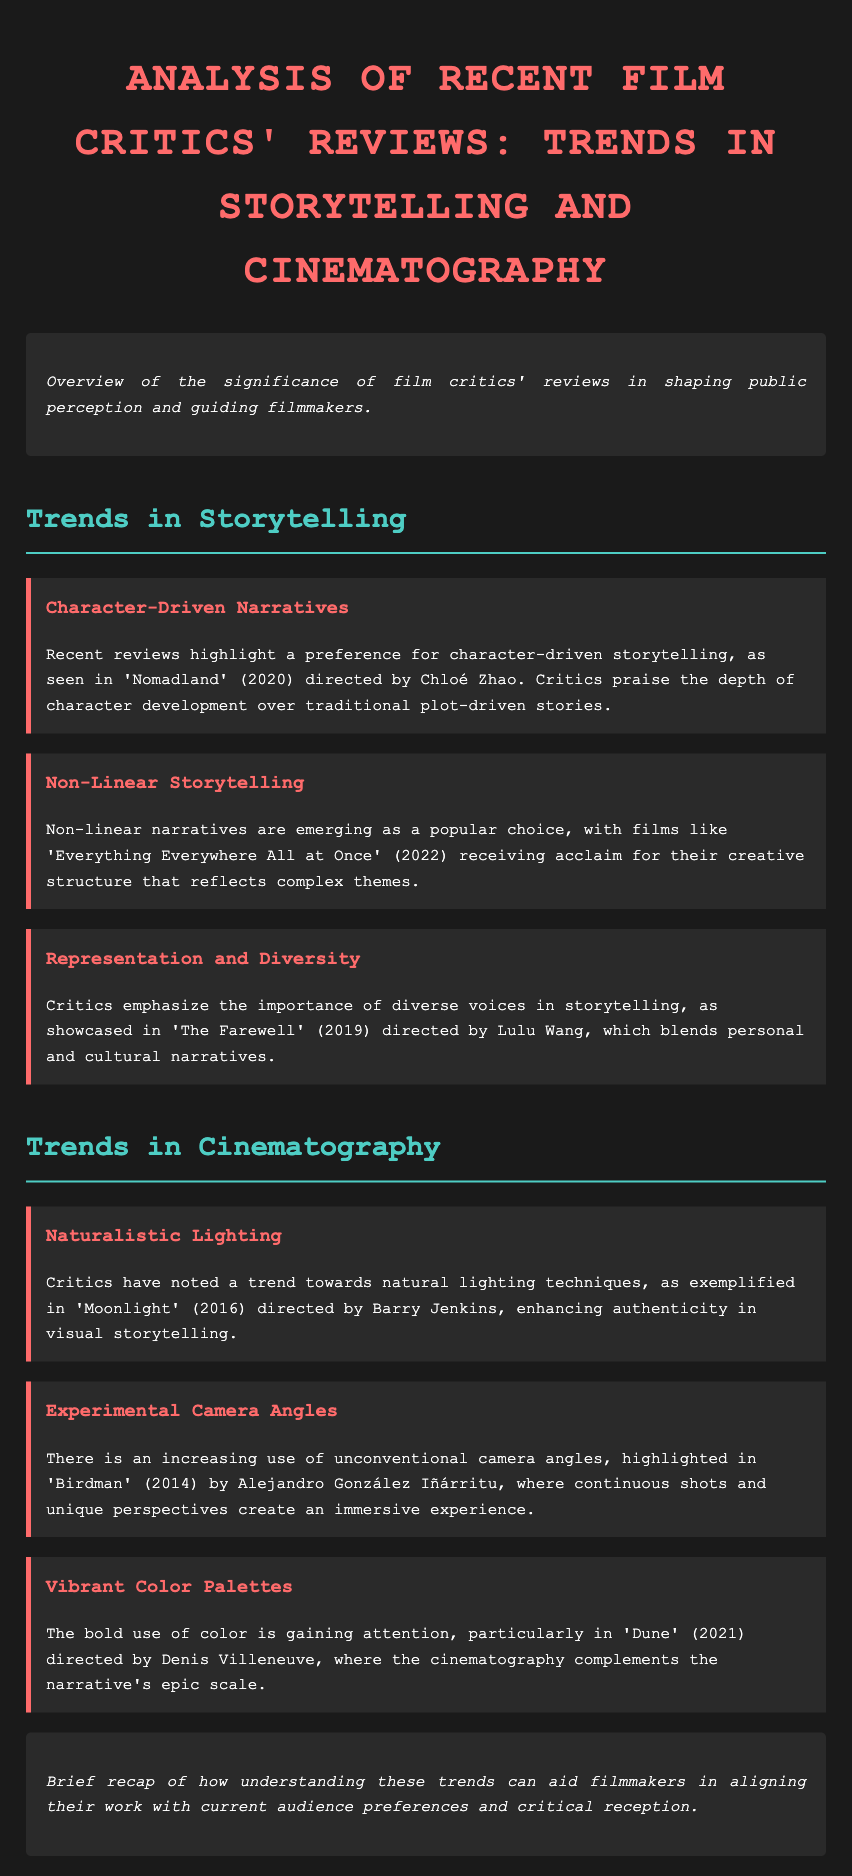What is the title of the document? The title of the document is prominently displayed at the top of the rendered document.
Answer: Analysis of Recent Film Critics' Reviews: Trends in Storytelling and Cinematography Who directed 'Nomadland'? 'Nomadland' is mentioned along with its director in the section about character-driven narratives.
Answer: Chloé Zhao What storytelling trend emphasizes character over plot? The trend related to character-driven narratives specifies a preference for character development over plot-driven stories.
Answer: Character-Driven Narratives Which film is noted for its non-linear storytelling technique? The document specifically highlights 'Everything Everywhere All at Once' for its creative narrative structure.
Answer: Everything Everywhere All at Once What lighting technique is emphasized in 'Moonlight'? The trend focusing on cinematography mentions the use of natural lighting techniques in 'Moonlight'.
Answer: Naturalistic Lighting Name a film that showcases vibrant color palettes. The document specifically describes 'Dune' as a film that uses bold color palettes.
Answer: Dune What aspect of storytelling do critics emphasize in 'The Farewell'? The section on representation and diversity discusses the blending of personal and cultural narratives in 'The Farewell'.
Answer: Diverse voices How many trends are listed under storytelling? The document outlines a specific number of themes regarding trends in storytelling.
Answer: Three What is a significant cinematographic trend mentioned in regards to 'Birdman'? This trend discusses the use of unconventional camera angles, particularly in 'Birdman'.
Answer: Experimental Camera Angles 